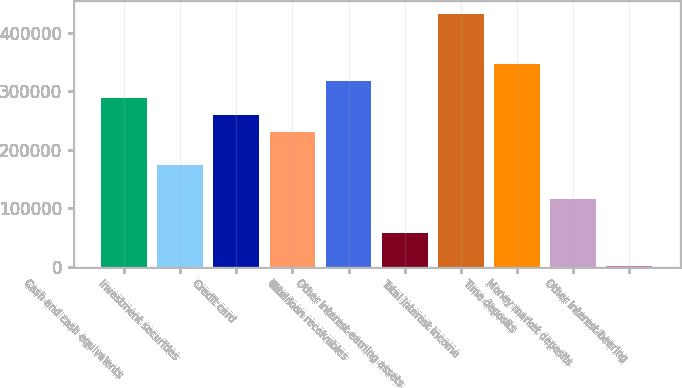Convert chart to OTSL. <chart><loc_0><loc_0><loc_500><loc_500><bar_chart><fcel>Cash and cash equivalents<fcel>Investment securities<fcel>Credit card<fcel>Other<fcel>Total loan receivables<fcel>Other interest-earning assets<fcel>Total interest income<fcel>Time deposits<fcel>Money market deposits<fcel>Other interest-bearing<nl><fcel>288431<fcel>173101<fcel>259599<fcel>230766<fcel>317263<fcel>57771.8<fcel>432593<fcel>346096<fcel>115437<fcel>107<nl></chart> 